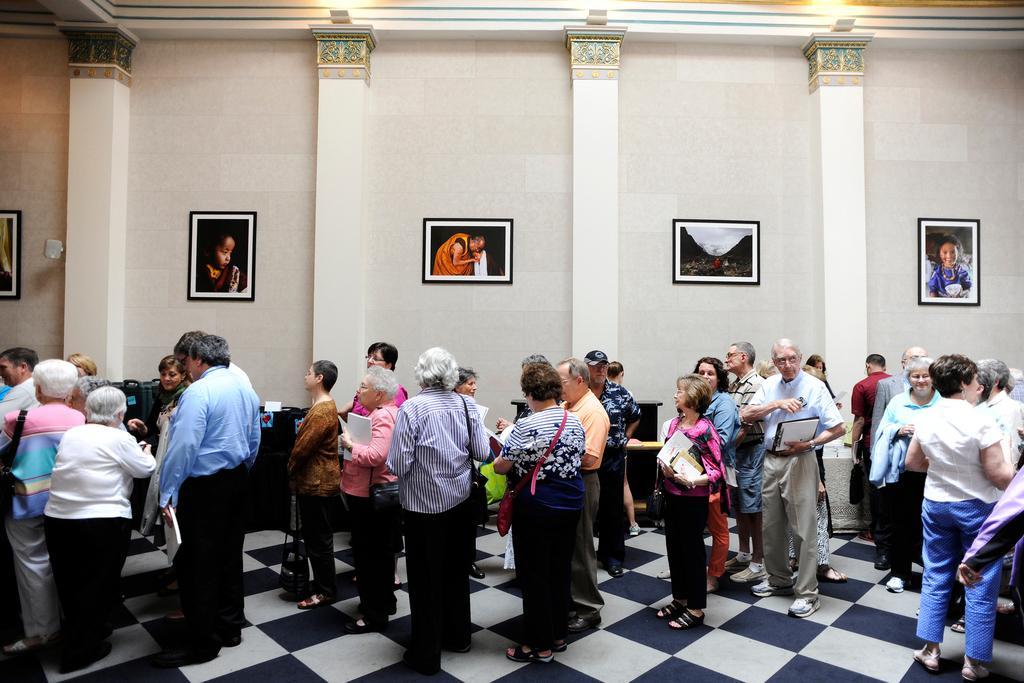How would you summarize this image in a sentence or two? In this picture, we see many people are standing and most of them are holding the books in their hands. In the background, we see the pillars and a white wall on which photo frames are placed. At the top, we see the lights and the ceiling of the room. At the bottom, we see the floor. 